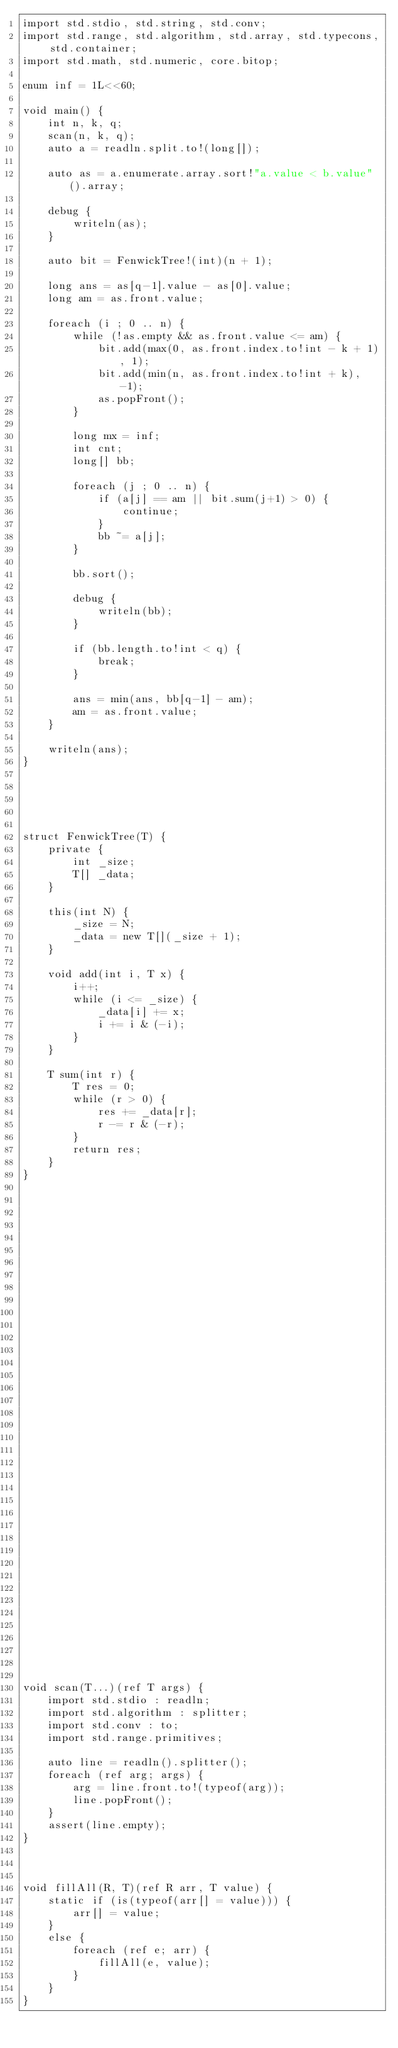<code> <loc_0><loc_0><loc_500><loc_500><_D_>import std.stdio, std.string, std.conv;
import std.range, std.algorithm, std.array, std.typecons, std.container;
import std.math, std.numeric, core.bitop;

enum inf = 1L<<60;

void main() {
    int n, k, q;
    scan(n, k, q);
    auto a = readln.split.to!(long[]);

    auto as = a.enumerate.array.sort!"a.value < b.value"().array;

    debug {
        writeln(as);
    }

    auto bit = FenwickTree!(int)(n + 1);

    long ans = as[q-1].value - as[0].value;
    long am = as.front.value;

    foreach (i ; 0 .. n) {
        while (!as.empty && as.front.value <= am) {
            bit.add(max(0, as.front.index.to!int - k + 1), 1);
            bit.add(min(n, as.front.index.to!int + k), -1);
            as.popFront();
        }

        long mx = inf;
        int cnt;
        long[] bb;

        foreach (j ; 0 .. n) {
            if (a[j] == am || bit.sum(j+1) > 0) {
                continue;
            }
            bb ~= a[j];
        }

        bb.sort();

        debug {
            writeln(bb);
        }

        if (bb.length.to!int < q) {
            break;
        }

        ans = min(ans, bb[q-1] - am);
        am = as.front.value;
    }

    writeln(ans);
}





struct FenwickTree(T) {
    private {
        int _size;
        T[] _data;
    }

    this(int N) {
        _size = N;
        _data = new T[](_size + 1);
    }

    void add(int i, T x) {
        i++;
        while (i <= _size) {
            _data[i] += x;
            i += i & (-i);
        }
    }

    T sum(int r) {
        T res = 0;
        while (r > 0) {
            res += _data[r];
            r -= r & (-r);
        }
        return res;
    }
}








































void scan(T...)(ref T args) {
    import std.stdio : readln;
    import std.algorithm : splitter;
    import std.conv : to;
    import std.range.primitives;

    auto line = readln().splitter();
    foreach (ref arg; args) {
        arg = line.front.to!(typeof(arg));
        line.popFront();
    }
    assert(line.empty);
}



void fillAll(R, T)(ref R arr, T value) {
    static if (is(typeof(arr[] = value))) {
        arr[] = value;
    }
    else {
        foreach (ref e; arr) {
            fillAll(e, value);
        }
    }
}
</code> 